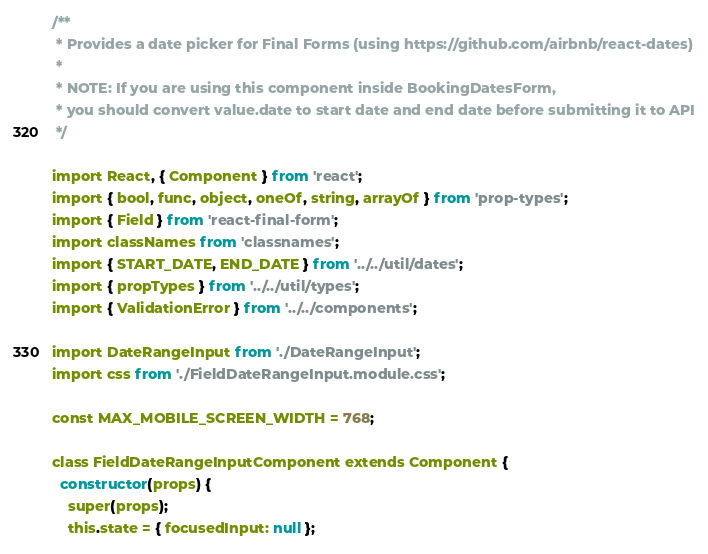<code> <loc_0><loc_0><loc_500><loc_500><_JavaScript_>/**
 * Provides a date picker for Final Forms (using https://github.com/airbnb/react-dates)
 *
 * NOTE: If you are using this component inside BookingDatesForm,
 * you should convert value.date to start date and end date before submitting it to API
 */

import React, { Component } from 'react';
import { bool, func, object, oneOf, string, arrayOf } from 'prop-types';
import { Field } from 'react-final-form';
import classNames from 'classnames';
import { START_DATE, END_DATE } from '../../util/dates';
import { propTypes } from '../../util/types';
import { ValidationError } from '../../components';

import DateRangeInput from './DateRangeInput';
import css from './FieldDateRangeInput.module.css';

const MAX_MOBILE_SCREEN_WIDTH = 768;

class FieldDateRangeInputComponent extends Component {
  constructor(props) {
    super(props);
    this.state = { focusedInput: null };</code> 